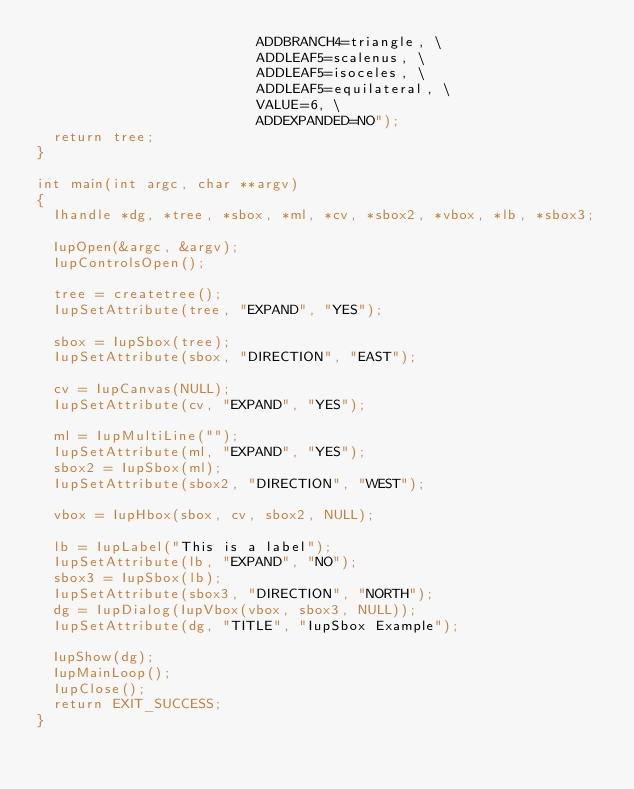Convert code to text. <code><loc_0><loc_0><loc_500><loc_500><_C_>                          ADDBRANCH4=triangle, \
                          ADDLEAF5=scalenus, \
                          ADDLEAF5=isoceles, \
                          ADDLEAF5=equilateral, \
                          VALUE=6, \
                          ADDEXPANDED=NO");
  return tree;
}

int main(int argc, char **argv)
{
  Ihandle *dg, *tree, *sbox, *ml, *cv, *sbox2, *vbox, *lb, *sbox3;

  IupOpen(&argc, &argv);
  IupControlsOpen();

  tree = createtree();
  IupSetAttribute(tree, "EXPAND", "YES");

  sbox = IupSbox(tree);
  IupSetAttribute(sbox, "DIRECTION", "EAST");

  cv = IupCanvas(NULL);
  IupSetAttribute(cv, "EXPAND", "YES");

  ml = IupMultiLine("");
  IupSetAttribute(ml, "EXPAND", "YES");
  sbox2 = IupSbox(ml);
  IupSetAttribute(sbox2, "DIRECTION", "WEST");

  vbox = IupHbox(sbox, cv, sbox2, NULL);

  lb = IupLabel("This is a label");
  IupSetAttribute(lb, "EXPAND", "NO");
  sbox3 = IupSbox(lb);
  IupSetAttribute(sbox3, "DIRECTION", "NORTH");
  dg = IupDialog(IupVbox(vbox, sbox3, NULL));
  IupSetAttribute(dg, "TITLE", "IupSbox Example");

  IupShow(dg);
  IupMainLoop();
  IupClose();
  return EXIT_SUCCESS;
}
</code> 